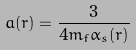<formula> <loc_0><loc_0><loc_500><loc_500>a ( r ) = \frac { 3 } { 4 m _ { f } \alpha _ { s } ( r ) }</formula> 